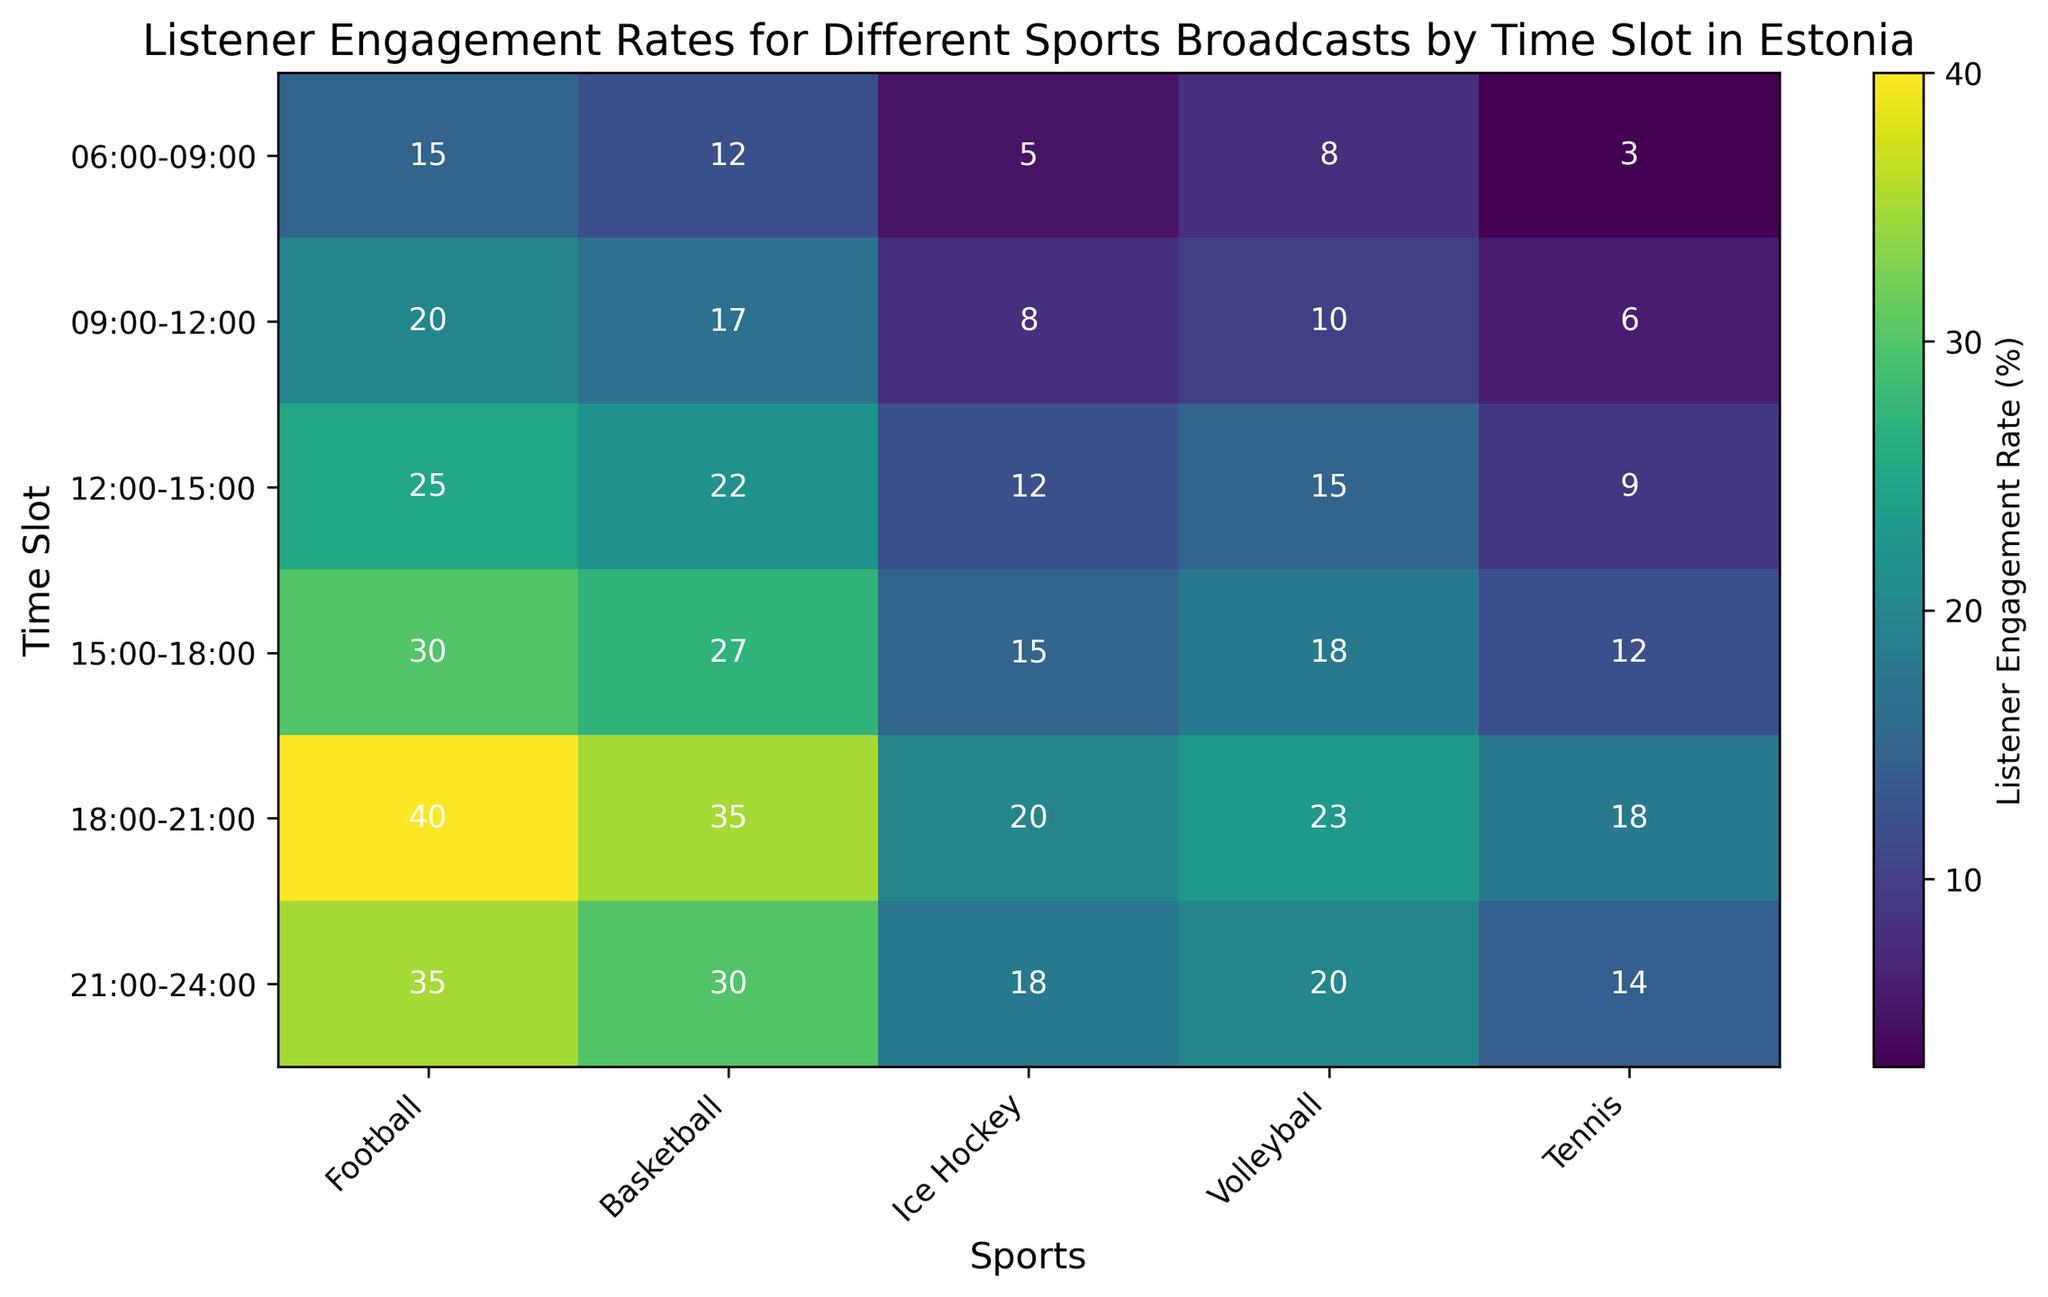How does the listener engagement rate for tennis differ between the 12:00-15:00 and 18:00-21:00 time slots? First, locate the engagement rates for tennis at both time slots on the heatmap. The rate for 12:00-15:00 is 9%, and for 18:00-21:00 it is 18%. Subtract 9% from 18% to find the difference.
Answer: 9% Which sport has the highest engagement rate in the 21:00-24:00 time slot? Locate the row corresponding to the 21:00-24:00 time slot and identify the maximum value. The highest engagement rate is 35% for football.
Answer: Football Between basketball and volleyball, which sport has a higher engagement rate on average throughout the day? Calculate the average engagement rate for each sport by summing the engagement rates across all time slots and dividing by the number of time slots (6). For basketball: (12 + 17 + 22 + 27 + 35 + 30) / 6 = 24. For volleyball: (8 + 10 + 15 + 18 + 23 + 20) / 6 = 15.5. Compare the averages.
Answer: Basketball During which time slot does ice hockey have the lowest engagement rate, and what is that rate? Review all the engagement rates for ice hockey across all time slots to find the smallest value. The lowest value is 5% during 06:00-09:00.
Answer: 06:00-09:00, 5% What is the total listener engagement rate for football throughout the day? Sum the engagement rates for football across all time slots: 15 + 20 + 25 + 30 + 40 + 35 = 165.
Answer: 165% How does the engagement rate for volleyball change from 06:00-09:00 to 15:00-18:00? Identify the engagement rates for volleyball at 06:00-09:00 and 15:00-18:00, which are 8% and 18% respectively. Calculate the change by subtracting the earlier value from the later one: 18% - 8% = 10%.
Answer: Increases by 10% Compare the engagement rates for basketball and ice hockey during the 18:00-21:00 time slot. Which one is higher and by how much? Locate the engagement rates for basketball and ice hockey during this time slot: basketball is 35%, and ice hockey is 20%. The difference is 35% - 20% = 15%. Basketball's rate is higher by 15%.
Answer: Basketball, by 15% Which sport shows a consistent increase in listener engagement rate throughout the day? Examine the engagement rates for each sport across all time slots to determine if any sport displays a consistently increasing trend. Football rates increase consistently: 15, 20, 25, 30, 40, 35.
Answer: Football 